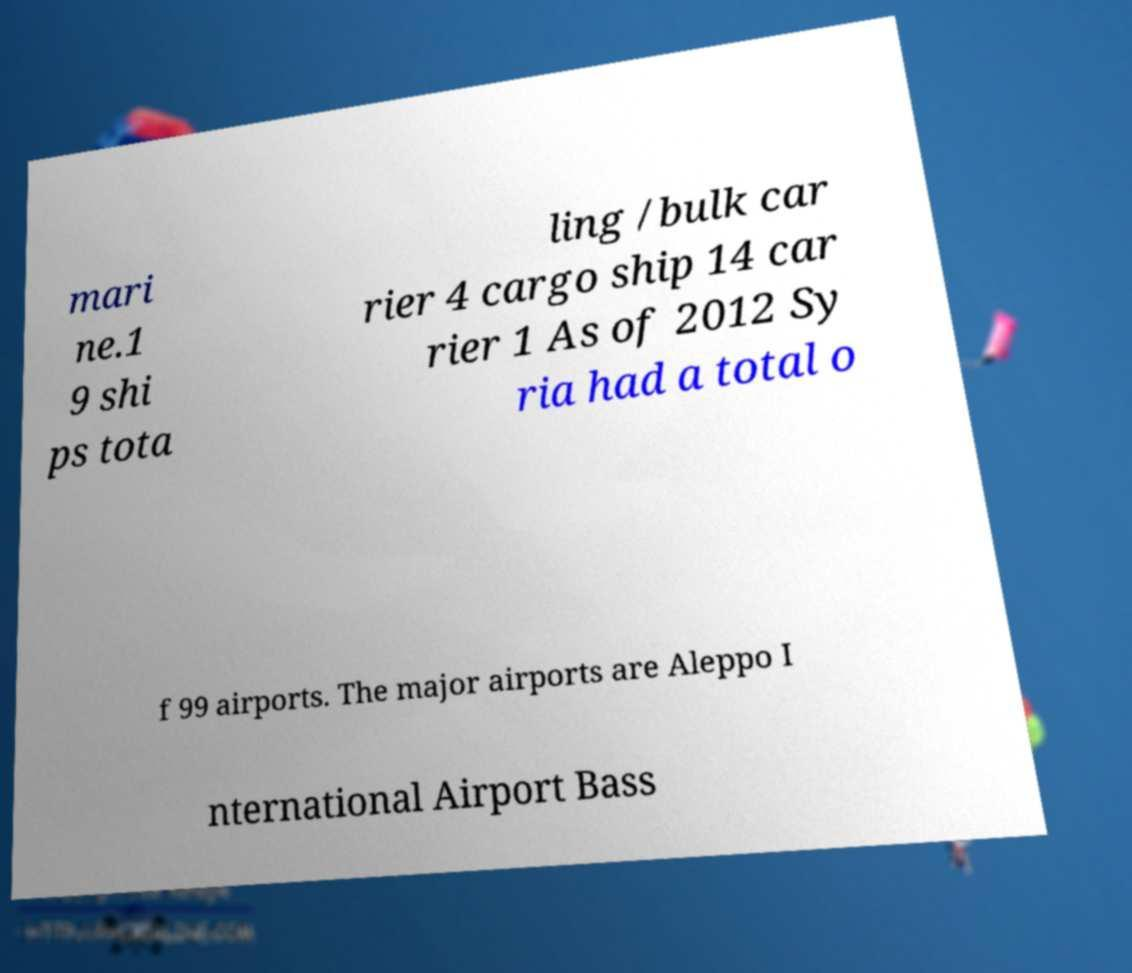Could you assist in decoding the text presented in this image and type it out clearly? mari ne.1 9 shi ps tota ling /bulk car rier 4 cargo ship 14 car rier 1 As of 2012 Sy ria had a total o f 99 airports. The major airports are Aleppo I nternational Airport Bass 